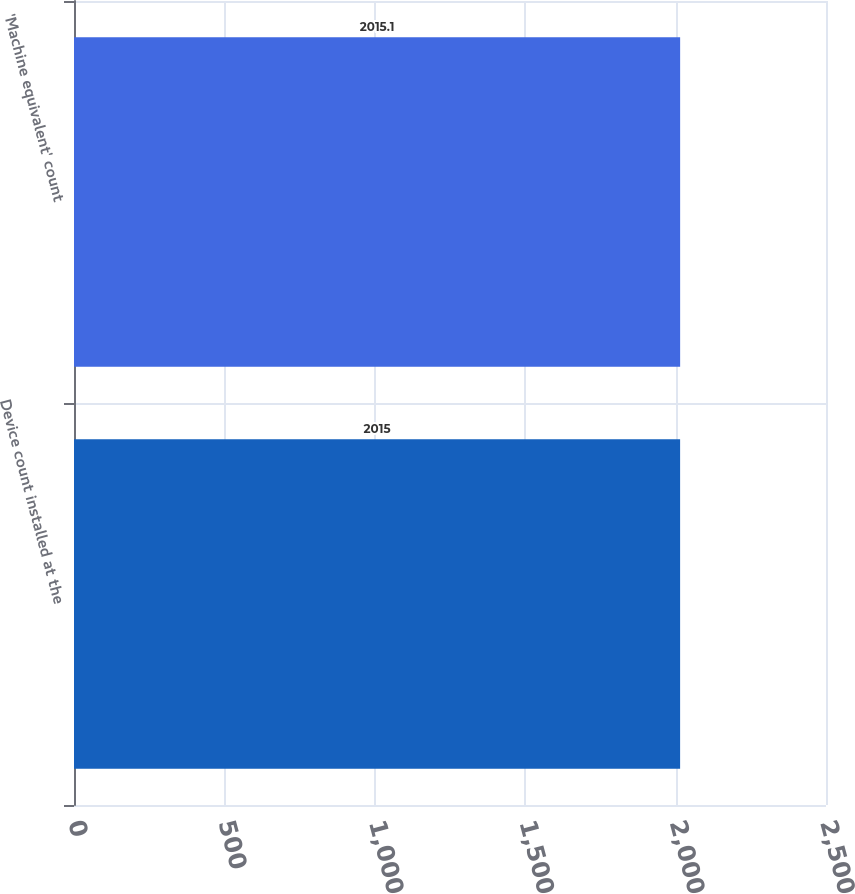<chart> <loc_0><loc_0><loc_500><loc_500><bar_chart><fcel>Device count installed at the<fcel>'Machine equivalent' count<nl><fcel>2015<fcel>2015.1<nl></chart> 